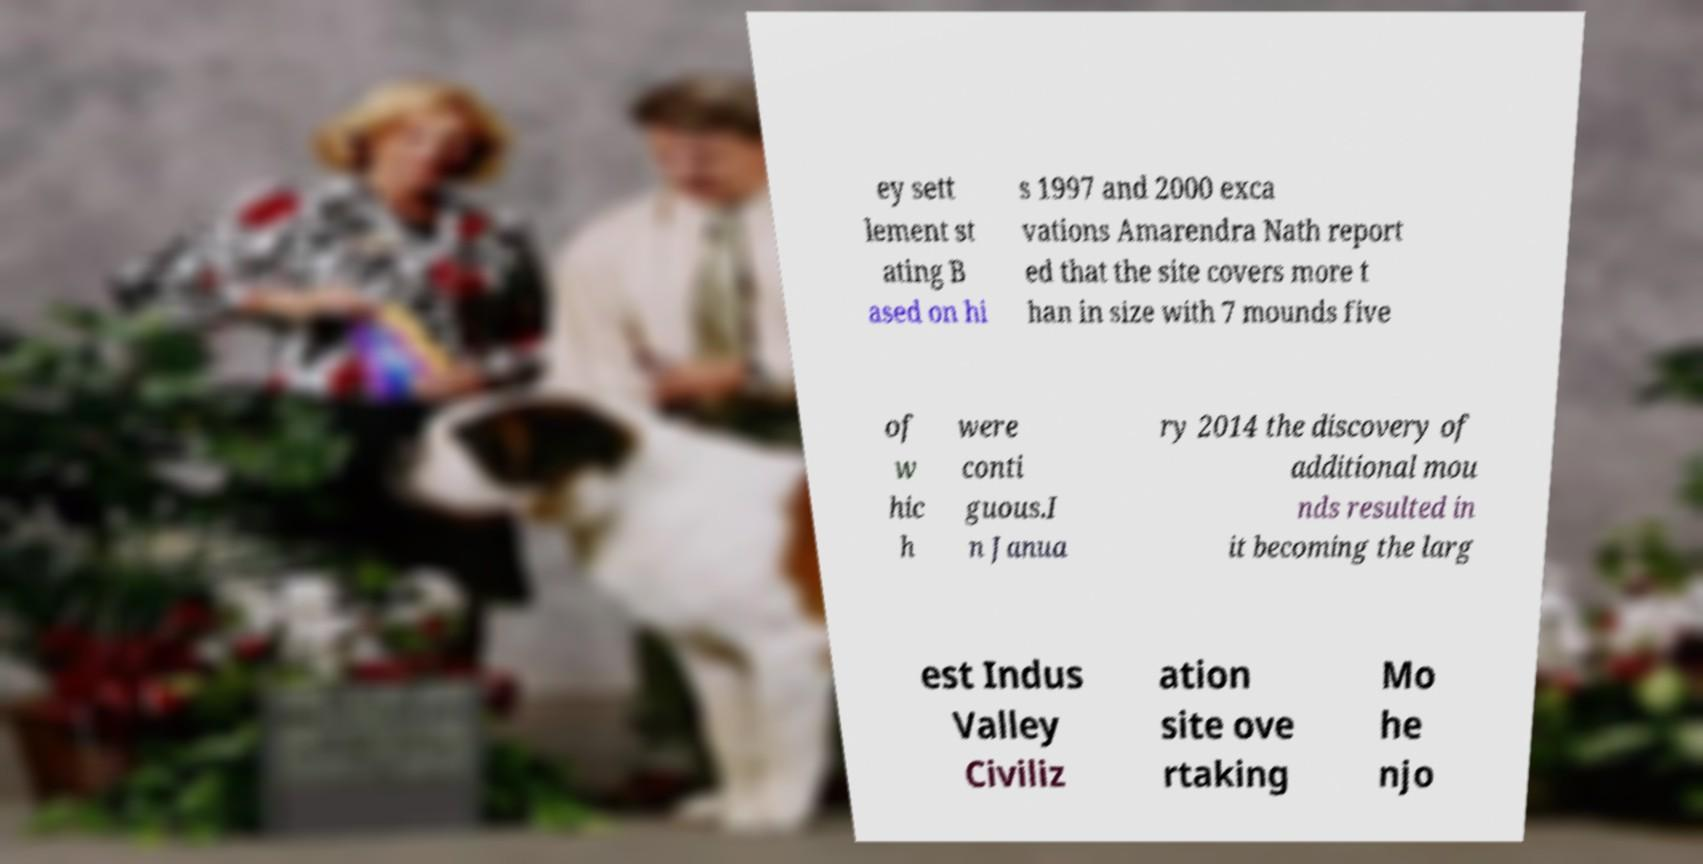Can you accurately transcribe the text from the provided image for me? ey sett lement st ating B ased on hi s 1997 and 2000 exca vations Amarendra Nath report ed that the site covers more t han in size with 7 mounds five of w hic h were conti guous.I n Janua ry 2014 the discovery of additional mou nds resulted in it becoming the larg est Indus Valley Civiliz ation site ove rtaking Mo he njo 